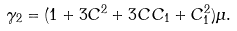Convert formula to latex. <formula><loc_0><loc_0><loc_500><loc_500>\gamma _ { 2 } = ( 1 + 3 C ^ { 2 } + 3 C C _ { 1 } + C _ { 1 } ^ { 2 } ) \mu .</formula> 